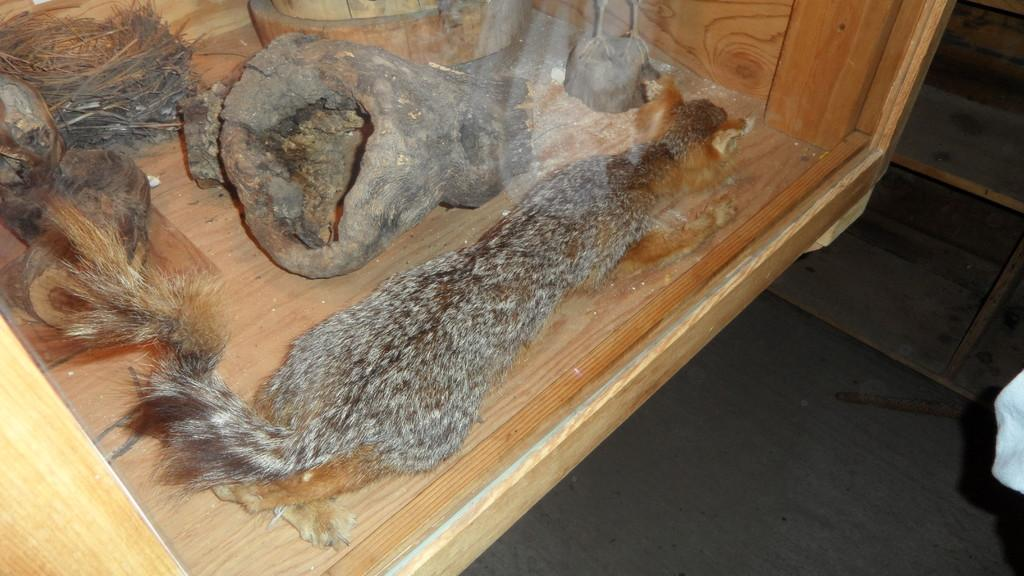What type of material is used to make the item in the image? There is an animal skin in the image. What can be found inside the wooden box in the image? There are objects in a wooden box. What is the wooden box made of? The wooden box has a glass. How many crowns are present in the image? There are no crowns present in the image. What rule is being enforced by the animal skin in the image? The animal skin in the image is not enforcing any rule. 